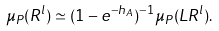<formula> <loc_0><loc_0><loc_500><loc_500>\mu _ { P } ( R ^ { l } ) \simeq ( 1 - e ^ { - h _ { A } } ) ^ { - 1 } \mu _ { P } ( L R ^ { l } ) .</formula> 